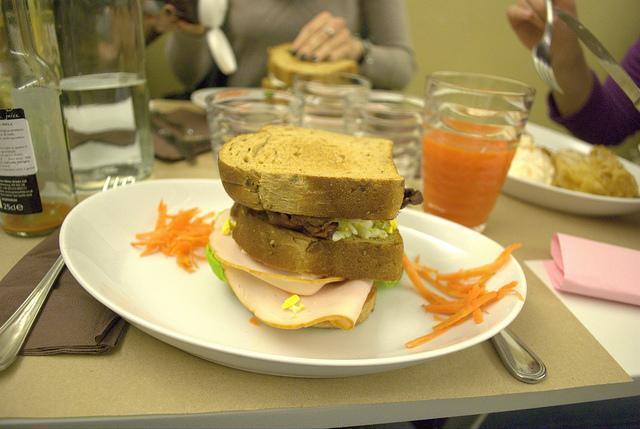How many sandwiches are visible in the photo?
Give a very brief answer. 2. How many cups are in the photo?
Give a very brief answer. 5. How many sandwiches are there?
Give a very brief answer. 2. How many people are there?
Give a very brief answer. 2. How many carrots are visible?
Give a very brief answer. 2. How many women on bikes are in the picture?
Give a very brief answer. 0. 